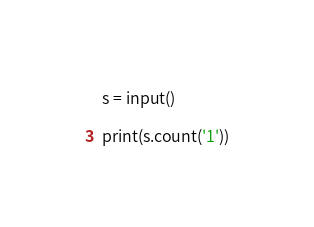Convert code to text. <code><loc_0><loc_0><loc_500><loc_500><_Python_>s = input()

print(s.count('1'))
</code> 